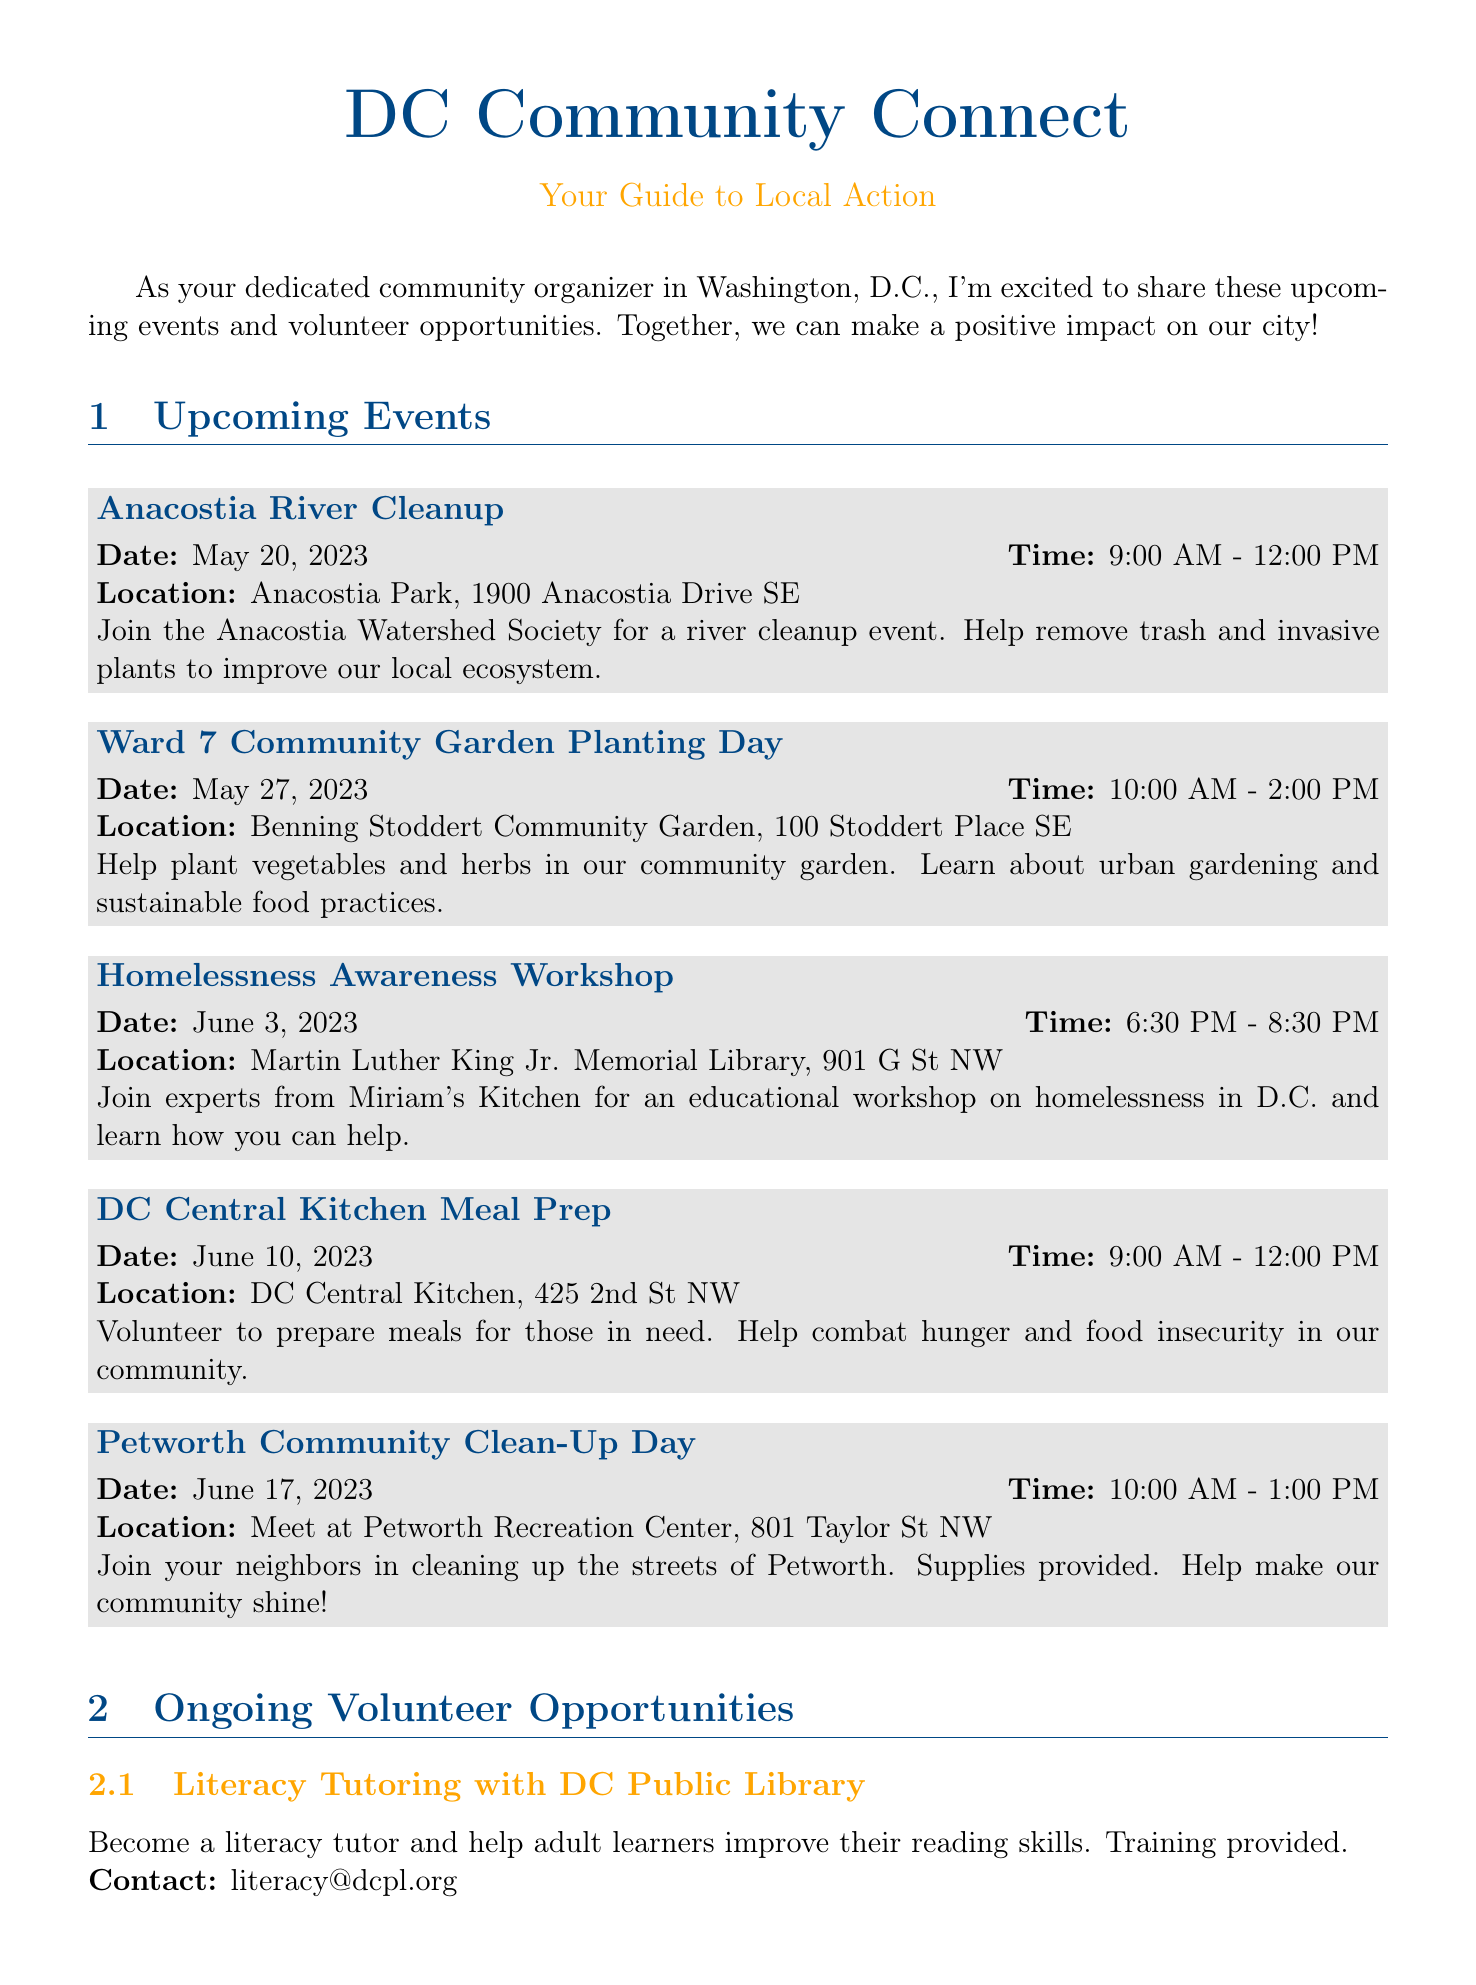what is the date of the Anacostia River Cleanup? The date for the Anacostia River Cleanup is specifically given in the document as May 20, 2023.
Answer: May 20, 2023 what time does the Homelessness Awareness Workshop start? The document states the start time of the Homelessness Awareness Workshop is 6:30 PM.
Answer: 6:30 PM where is the Ward 7 Community Garden Planting Day located? The location for the Ward 7 Community Garden Planting Day is detailed in the document as Benning Stoddert Community Garden, 100 Stoddert Place SE.
Answer: Benning Stoddert Community Garden, 100 Stoddert Place SE how many ongoing volunteer opportunities are listed? The document provides a total of three ongoing volunteer opportunities.
Answer: 3 what type of event is scheduled for June 10, 2023? The event scheduled for June 10, 2023, is a meal prep event with DC Central Kitchen, which is a volunteering opportunity.
Answer: Meal Prep who can be contacted for Literacy Tutoring with DC Public Library? The document provides the contact email for Literacy Tutoring with DC Public Library as literacy@dcpl.org.
Answer: literacy@dcpl.org which event focuses on homelessness awareness? The document specifies that the event focused on homelessness awareness is the Homelessness Awareness Workshop.
Answer: Homelessness Awareness Workshop what is the purpose of the DC Central Kitchen Meal Prep? The purpose of the DC Central Kitchen Meal Prep is to prepare meals for those in need and combat hunger in the community according to the document.
Answer: Prepare meals for those in need what is the call to action in the newsletter? The call to action encourages readers to sign up for events or ongoing opportunities by emailing or calling the organizer.
Answer: To sign up for any of these events or ongoing opportunities, please email me at organizer@dccommunityconnect.org or call 202-555-0123 